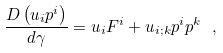<formula> <loc_0><loc_0><loc_500><loc_500>\frac { D \left ( u _ { i } p ^ { i } \right ) } { d \gamma } = u _ { i } F ^ { i } + u _ { i ; k } p ^ { i } p ^ { k } \ ,</formula> 